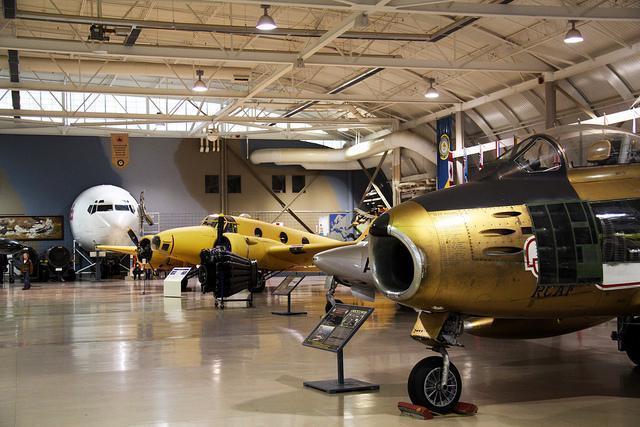How many airplanes are in the photo?
Give a very brief answer. 4. 